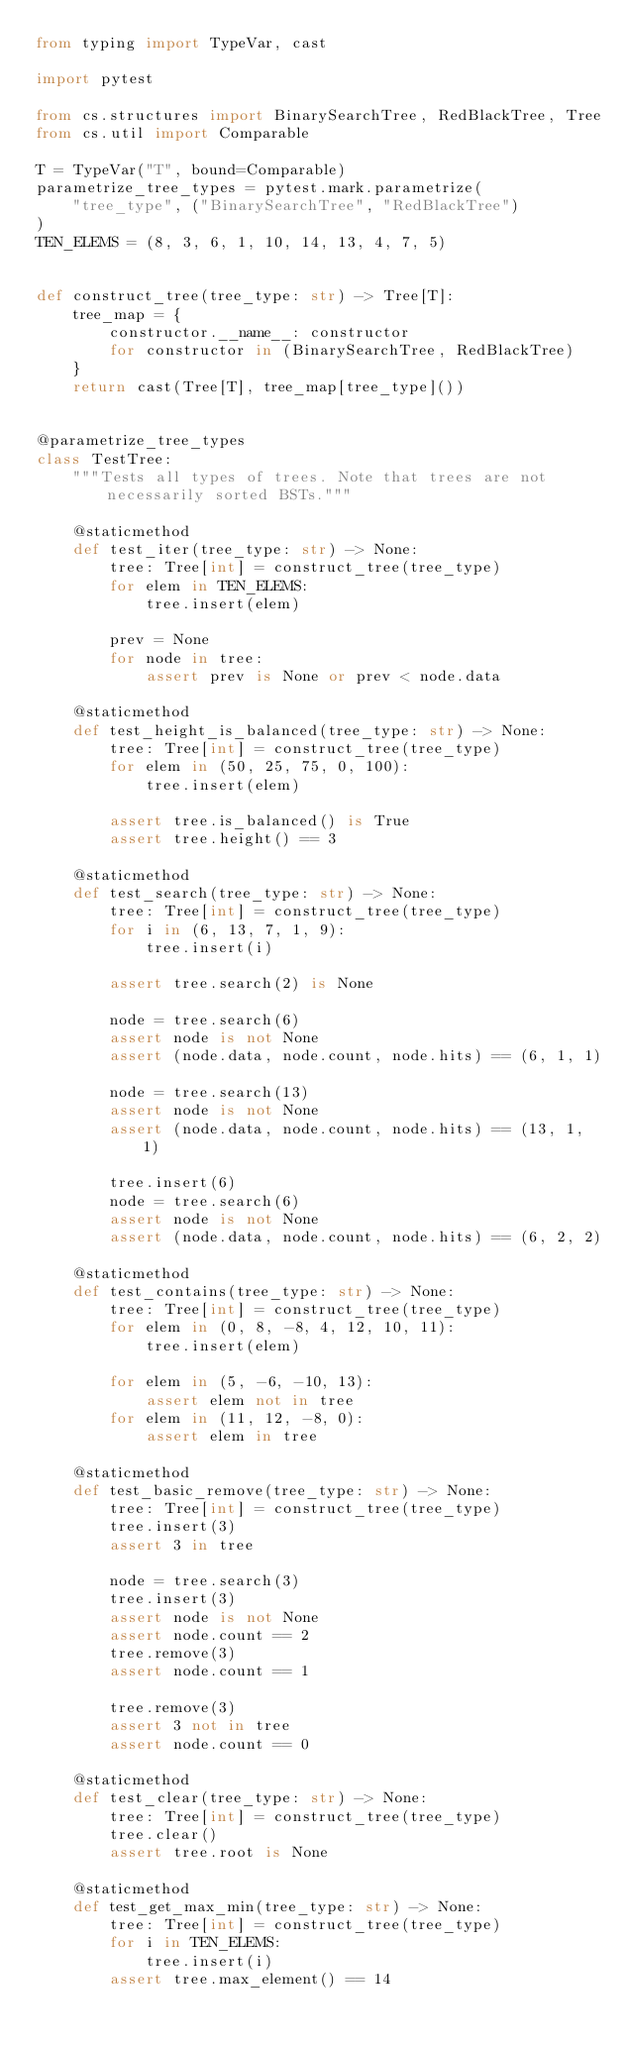<code> <loc_0><loc_0><loc_500><loc_500><_Python_>from typing import TypeVar, cast

import pytest

from cs.structures import BinarySearchTree, RedBlackTree, Tree
from cs.util import Comparable

T = TypeVar("T", bound=Comparable)
parametrize_tree_types = pytest.mark.parametrize(
    "tree_type", ("BinarySearchTree", "RedBlackTree")
)
TEN_ELEMS = (8, 3, 6, 1, 10, 14, 13, 4, 7, 5)


def construct_tree(tree_type: str) -> Tree[T]:
    tree_map = {
        constructor.__name__: constructor
        for constructor in (BinarySearchTree, RedBlackTree)
    }
    return cast(Tree[T], tree_map[tree_type]())


@parametrize_tree_types
class TestTree:
    """Tests all types of trees. Note that trees are not necessarily sorted BSTs."""

    @staticmethod
    def test_iter(tree_type: str) -> None:
        tree: Tree[int] = construct_tree(tree_type)
        for elem in TEN_ELEMS:
            tree.insert(elem)

        prev = None
        for node in tree:
            assert prev is None or prev < node.data

    @staticmethod
    def test_height_is_balanced(tree_type: str) -> None:
        tree: Tree[int] = construct_tree(tree_type)
        for elem in (50, 25, 75, 0, 100):
            tree.insert(elem)

        assert tree.is_balanced() is True
        assert tree.height() == 3

    @staticmethod
    def test_search(tree_type: str) -> None:
        tree: Tree[int] = construct_tree(tree_type)
        for i in (6, 13, 7, 1, 9):
            tree.insert(i)

        assert tree.search(2) is None

        node = tree.search(6)
        assert node is not None
        assert (node.data, node.count, node.hits) == (6, 1, 1)

        node = tree.search(13)
        assert node is not None
        assert (node.data, node.count, node.hits) == (13, 1, 1)

        tree.insert(6)
        node = tree.search(6)
        assert node is not None
        assert (node.data, node.count, node.hits) == (6, 2, 2)

    @staticmethod
    def test_contains(tree_type: str) -> None:
        tree: Tree[int] = construct_tree(tree_type)
        for elem in (0, 8, -8, 4, 12, 10, 11):
            tree.insert(elem)

        for elem in (5, -6, -10, 13):
            assert elem not in tree
        for elem in (11, 12, -8, 0):
            assert elem in tree

    @staticmethod
    def test_basic_remove(tree_type: str) -> None:
        tree: Tree[int] = construct_tree(tree_type)
        tree.insert(3)
        assert 3 in tree

        node = tree.search(3)
        tree.insert(3)
        assert node is not None
        assert node.count == 2
        tree.remove(3)
        assert node.count == 1

        tree.remove(3)
        assert 3 not in tree
        assert node.count == 0

    @staticmethod
    def test_clear(tree_type: str) -> None:
        tree: Tree[int] = construct_tree(tree_type)
        tree.clear()
        assert tree.root is None

    @staticmethod
    def test_get_max_min(tree_type: str) -> None:
        tree: Tree[int] = construct_tree(tree_type)
        for i in TEN_ELEMS:
            tree.insert(i)
        assert tree.max_element() == 14</code> 